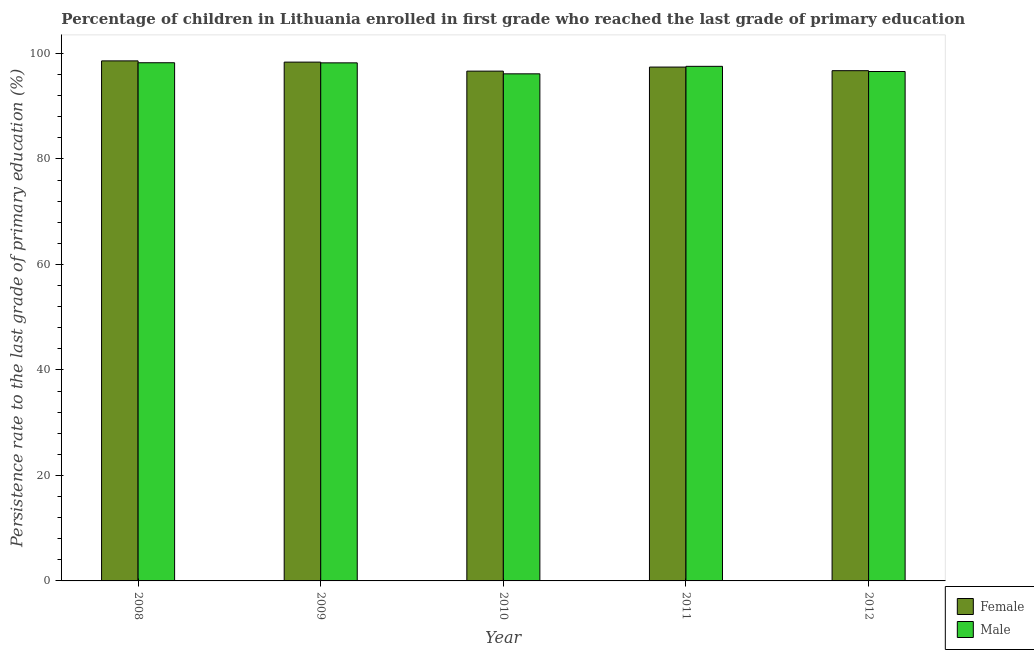How many different coloured bars are there?
Offer a terse response. 2. Are the number of bars per tick equal to the number of legend labels?
Offer a very short reply. Yes. Are the number of bars on each tick of the X-axis equal?
Your answer should be very brief. Yes. How many bars are there on the 4th tick from the right?
Offer a terse response. 2. What is the persistence rate of male students in 2009?
Your answer should be compact. 98.23. Across all years, what is the maximum persistence rate of female students?
Provide a succinct answer. 98.6. Across all years, what is the minimum persistence rate of female students?
Your answer should be compact. 96.66. In which year was the persistence rate of male students maximum?
Offer a very short reply. 2008. In which year was the persistence rate of female students minimum?
Your answer should be compact. 2010. What is the total persistence rate of male students in the graph?
Offer a terse response. 486.78. What is the difference between the persistence rate of female students in 2009 and that in 2010?
Offer a very short reply. 1.71. What is the difference between the persistence rate of female students in 2012 and the persistence rate of male students in 2010?
Your answer should be compact. 0.08. What is the average persistence rate of female students per year?
Your response must be concise. 97.56. In the year 2012, what is the difference between the persistence rate of female students and persistence rate of male students?
Make the answer very short. 0. In how many years, is the persistence rate of female students greater than 60 %?
Offer a very short reply. 5. What is the ratio of the persistence rate of male students in 2010 to that in 2012?
Your response must be concise. 1. Is the difference between the persistence rate of male students in 2011 and 2012 greater than the difference between the persistence rate of female students in 2011 and 2012?
Provide a succinct answer. No. What is the difference between the highest and the second highest persistence rate of female students?
Provide a short and direct response. 0.23. What is the difference between the highest and the lowest persistence rate of female students?
Ensure brevity in your answer.  1.94. How many years are there in the graph?
Offer a very short reply. 5. Are the values on the major ticks of Y-axis written in scientific E-notation?
Keep it short and to the point. No. How many legend labels are there?
Keep it short and to the point. 2. How are the legend labels stacked?
Offer a terse response. Vertical. What is the title of the graph?
Make the answer very short. Percentage of children in Lithuania enrolled in first grade who reached the last grade of primary education. What is the label or title of the Y-axis?
Offer a terse response. Persistence rate to the last grade of primary education (%). What is the Persistence rate to the last grade of primary education (%) in Female in 2008?
Keep it short and to the point. 98.6. What is the Persistence rate to the last grade of primary education (%) of Male in 2008?
Your answer should be very brief. 98.25. What is the Persistence rate to the last grade of primary education (%) in Female in 2009?
Your response must be concise. 98.37. What is the Persistence rate to the last grade of primary education (%) in Male in 2009?
Your answer should be very brief. 98.23. What is the Persistence rate to the last grade of primary education (%) in Female in 2010?
Provide a succinct answer. 96.66. What is the Persistence rate to the last grade of primary education (%) of Male in 2010?
Your response must be concise. 96.15. What is the Persistence rate to the last grade of primary education (%) in Female in 2011?
Give a very brief answer. 97.43. What is the Persistence rate to the last grade of primary education (%) of Male in 2011?
Ensure brevity in your answer.  97.57. What is the Persistence rate to the last grade of primary education (%) of Female in 2012?
Make the answer very short. 96.74. What is the Persistence rate to the last grade of primary education (%) in Male in 2012?
Provide a succinct answer. 96.59. Across all years, what is the maximum Persistence rate to the last grade of primary education (%) of Female?
Offer a very short reply. 98.6. Across all years, what is the maximum Persistence rate to the last grade of primary education (%) of Male?
Make the answer very short. 98.25. Across all years, what is the minimum Persistence rate to the last grade of primary education (%) in Female?
Your answer should be compact. 96.66. Across all years, what is the minimum Persistence rate to the last grade of primary education (%) of Male?
Offer a very short reply. 96.15. What is the total Persistence rate to the last grade of primary education (%) in Female in the graph?
Make the answer very short. 487.8. What is the total Persistence rate to the last grade of primary education (%) of Male in the graph?
Make the answer very short. 486.78. What is the difference between the Persistence rate to the last grade of primary education (%) of Female in 2008 and that in 2009?
Provide a succinct answer. 0.23. What is the difference between the Persistence rate to the last grade of primary education (%) of Male in 2008 and that in 2009?
Your answer should be very brief. 0.02. What is the difference between the Persistence rate to the last grade of primary education (%) in Female in 2008 and that in 2010?
Offer a terse response. 1.94. What is the difference between the Persistence rate to the last grade of primary education (%) in Male in 2008 and that in 2010?
Your answer should be compact. 2.1. What is the difference between the Persistence rate to the last grade of primary education (%) in Female in 2008 and that in 2011?
Your answer should be very brief. 1.17. What is the difference between the Persistence rate to the last grade of primary education (%) in Male in 2008 and that in 2011?
Your answer should be very brief. 0.68. What is the difference between the Persistence rate to the last grade of primary education (%) of Female in 2008 and that in 2012?
Provide a succinct answer. 1.86. What is the difference between the Persistence rate to the last grade of primary education (%) in Male in 2008 and that in 2012?
Your response must be concise. 1.66. What is the difference between the Persistence rate to the last grade of primary education (%) of Female in 2009 and that in 2010?
Your answer should be compact. 1.71. What is the difference between the Persistence rate to the last grade of primary education (%) of Male in 2009 and that in 2010?
Ensure brevity in your answer.  2.08. What is the difference between the Persistence rate to the last grade of primary education (%) in Female in 2009 and that in 2011?
Your answer should be compact. 0.94. What is the difference between the Persistence rate to the last grade of primary education (%) of Male in 2009 and that in 2011?
Make the answer very short. 0.66. What is the difference between the Persistence rate to the last grade of primary education (%) of Female in 2009 and that in 2012?
Give a very brief answer. 1.63. What is the difference between the Persistence rate to the last grade of primary education (%) of Male in 2009 and that in 2012?
Provide a short and direct response. 1.64. What is the difference between the Persistence rate to the last grade of primary education (%) in Female in 2010 and that in 2011?
Your answer should be compact. -0.77. What is the difference between the Persistence rate to the last grade of primary education (%) of Male in 2010 and that in 2011?
Give a very brief answer. -1.42. What is the difference between the Persistence rate to the last grade of primary education (%) of Female in 2010 and that in 2012?
Ensure brevity in your answer.  -0.09. What is the difference between the Persistence rate to the last grade of primary education (%) in Male in 2010 and that in 2012?
Ensure brevity in your answer.  -0.44. What is the difference between the Persistence rate to the last grade of primary education (%) in Female in 2011 and that in 2012?
Provide a succinct answer. 0.69. What is the difference between the Persistence rate to the last grade of primary education (%) of Male in 2011 and that in 2012?
Your answer should be compact. 0.98. What is the difference between the Persistence rate to the last grade of primary education (%) of Female in 2008 and the Persistence rate to the last grade of primary education (%) of Male in 2009?
Give a very brief answer. 0.38. What is the difference between the Persistence rate to the last grade of primary education (%) of Female in 2008 and the Persistence rate to the last grade of primary education (%) of Male in 2010?
Offer a terse response. 2.46. What is the difference between the Persistence rate to the last grade of primary education (%) of Female in 2008 and the Persistence rate to the last grade of primary education (%) of Male in 2011?
Ensure brevity in your answer.  1.03. What is the difference between the Persistence rate to the last grade of primary education (%) of Female in 2008 and the Persistence rate to the last grade of primary education (%) of Male in 2012?
Offer a terse response. 2.01. What is the difference between the Persistence rate to the last grade of primary education (%) of Female in 2009 and the Persistence rate to the last grade of primary education (%) of Male in 2010?
Ensure brevity in your answer.  2.22. What is the difference between the Persistence rate to the last grade of primary education (%) in Female in 2009 and the Persistence rate to the last grade of primary education (%) in Male in 2011?
Keep it short and to the point. 0.8. What is the difference between the Persistence rate to the last grade of primary education (%) of Female in 2009 and the Persistence rate to the last grade of primary education (%) of Male in 2012?
Offer a very short reply. 1.78. What is the difference between the Persistence rate to the last grade of primary education (%) in Female in 2010 and the Persistence rate to the last grade of primary education (%) in Male in 2011?
Make the answer very short. -0.91. What is the difference between the Persistence rate to the last grade of primary education (%) in Female in 2010 and the Persistence rate to the last grade of primary education (%) in Male in 2012?
Make the answer very short. 0.07. What is the difference between the Persistence rate to the last grade of primary education (%) in Female in 2011 and the Persistence rate to the last grade of primary education (%) in Male in 2012?
Offer a terse response. 0.84. What is the average Persistence rate to the last grade of primary education (%) of Female per year?
Give a very brief answer. 97.56. What is the average Persistence rate to the last grade of primary education (%) of Male per year?
Provide a short and direct response. 97.36. In the year 2008, what is the difference between the Persistence rate to the last grade of primary education (%) of Female and Persistence rate to the last grade of primary education (%) of Male?
Offer a very short reply. 0.35. In the year 2009, what is the difference between the Persistence rate to the last grade of primary education (%) in Female and Persistence rate to the last grade of primary education (%) in Male?
Your answer should be very brief. 0.14. In the year 2010, what is the difference between the Persistence rate to the last grade of primary education (%) in Female and Persistence rate to the last grade of primary education (%) in Male?
Offer a very short reply. 0.51. In the year 2011, what is the difference between the Persistence rate to the last grade of primary education (%) of Female and Persistence rate to the last grade of primary education (%) of Male?
Offer a terse response. -0.14. In the year 2012, what is the difference between the Persistence rate to the last grade of primary education (%) of Female and Persistence rate to the last grade of primary education (%) of Male?
Your answer should be very brief. 0.15. What is the ratio of the Persistence rate to the last grade of primary education (%) in Female in 2008 to that in 2010?
Give a very brief answer. 1.02. What is the ratio of the Persistence rate to the last grade of primary education (%) of Male in 2008 to that in 2010?
Your answer should be very brief. 1.02. What is the ratio of the Persistence rate to the last grade of primary education (%) of Female in 2008 to that in 2011?
Your answer should be very brief. 1.01. What is the ratio of the Persistence rate to the last grade of primary education (%) of Female in 2008 to that in 2012?
Provide a succinct answer. 1.02. What is the ratio of the Persistence rate to the last grade of primary education (%) in Male in 2008 to that in 2012?
Give a very brief answer. 1.02. What is the ratio of the Persistence rate to the last grade of primary education (%) in Female in 2009 to that in 2010?
Offer a very short reply. 1.02. What is the ratio of the Persistence rate to the last grade of primary education (%) of Male in 2009 to that in 2010?
Your response must be concise. 1.02. What is the ratio of the Persistence rate to the last grade of primary education (%) of Female in 2009 to that in 2011?
Keep it short and to the point. 1.01. What is the ratio of the Persistence rate to the last grade of primary education (%) in Male in 2009 to that in 2011?
Your answer should be very brief. 1.01. What is the ratio of the Persistence rate to the last grade of primary education (%) of Female in 2009 to that in 2012?
Provide a succinct answer. 1.02. What is the ratio of the Persistence rate to the last grade of primary education (%) of Male in 2009 to that in 2012?
Ensure brevity in your answer.  1.02. What is the ratio of the Persistence rate to the last grade of primary education (%) in Female in 2010 to that in 2011?
Your response must be concise. 0.99. What is the ratio of the Persistence rate to the last grade of primary education (%) in Male in 2010 to that in 2011?
Your response must be concise. 0.99. What is the ratio of the Persistence rate to the last grade of primary education (%) in Female in 2011 to that in 2012?
Keep it short and to the point. 1.01. What is the ratio of the Persistence rate to the last grade of primary education (%) in Male in 2011 to that in 2012?
Your answer should be very brief. 1.01. What is the difference between the highest and the second highest Persistence rate to the last grade of primary education (%) of Female?
Offer a very short reply. 0.23. What is the difference between the highest and the second highest Persistence rate to the last grade of primary education (%) of Male?
Offer a terse response. 0.02. What is the difference between the highest and the lowest Persistence rate to the last grade of primary education (%) of Female?
Provide a short and direct response. 1.94. What is the difference between the highest and the lowest Persistence rate to the last grade of primary education (%) of Male?
Your response must be concise. 2.1. 